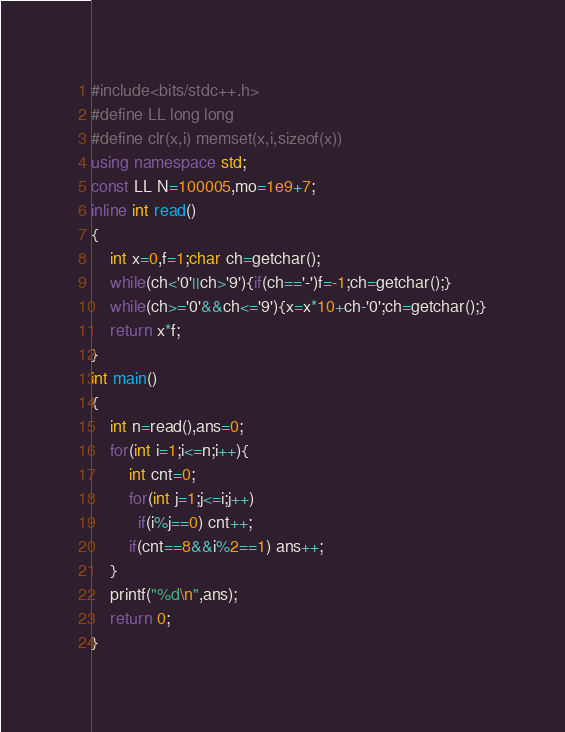<code> <loc_0><loc_0><loc_500><loc_500><_C++_>#include<bits/stdc++.h>
#define LL long long
#define clr(x,i) memset(x,i,sizeof(x))
using namespace std;
const LL N=100005,mo=1e9+7;
inline int read()
{
	int x=0,f=1;char ch=getchar();
	while(ch<'0'||ch>'9'){if(ch=='-')f=-1;ch=getchar();}
	while(ch>='0'&&ch<='9'){x=x*10+ch-'0';ch=getchar();}
	return x*f;
}
int main()
{
	int n=read(),ans=0;
	for(int i=1;i<=n;i++){
		int cnt=0;
		for(int j=1;j<=i;j++)
		  if(i%j==0) cnt++;
		if(cnt==8&&i%2==1) ans++;
	}
	printf("%d\n",ans);
	return 0;
}</code> 